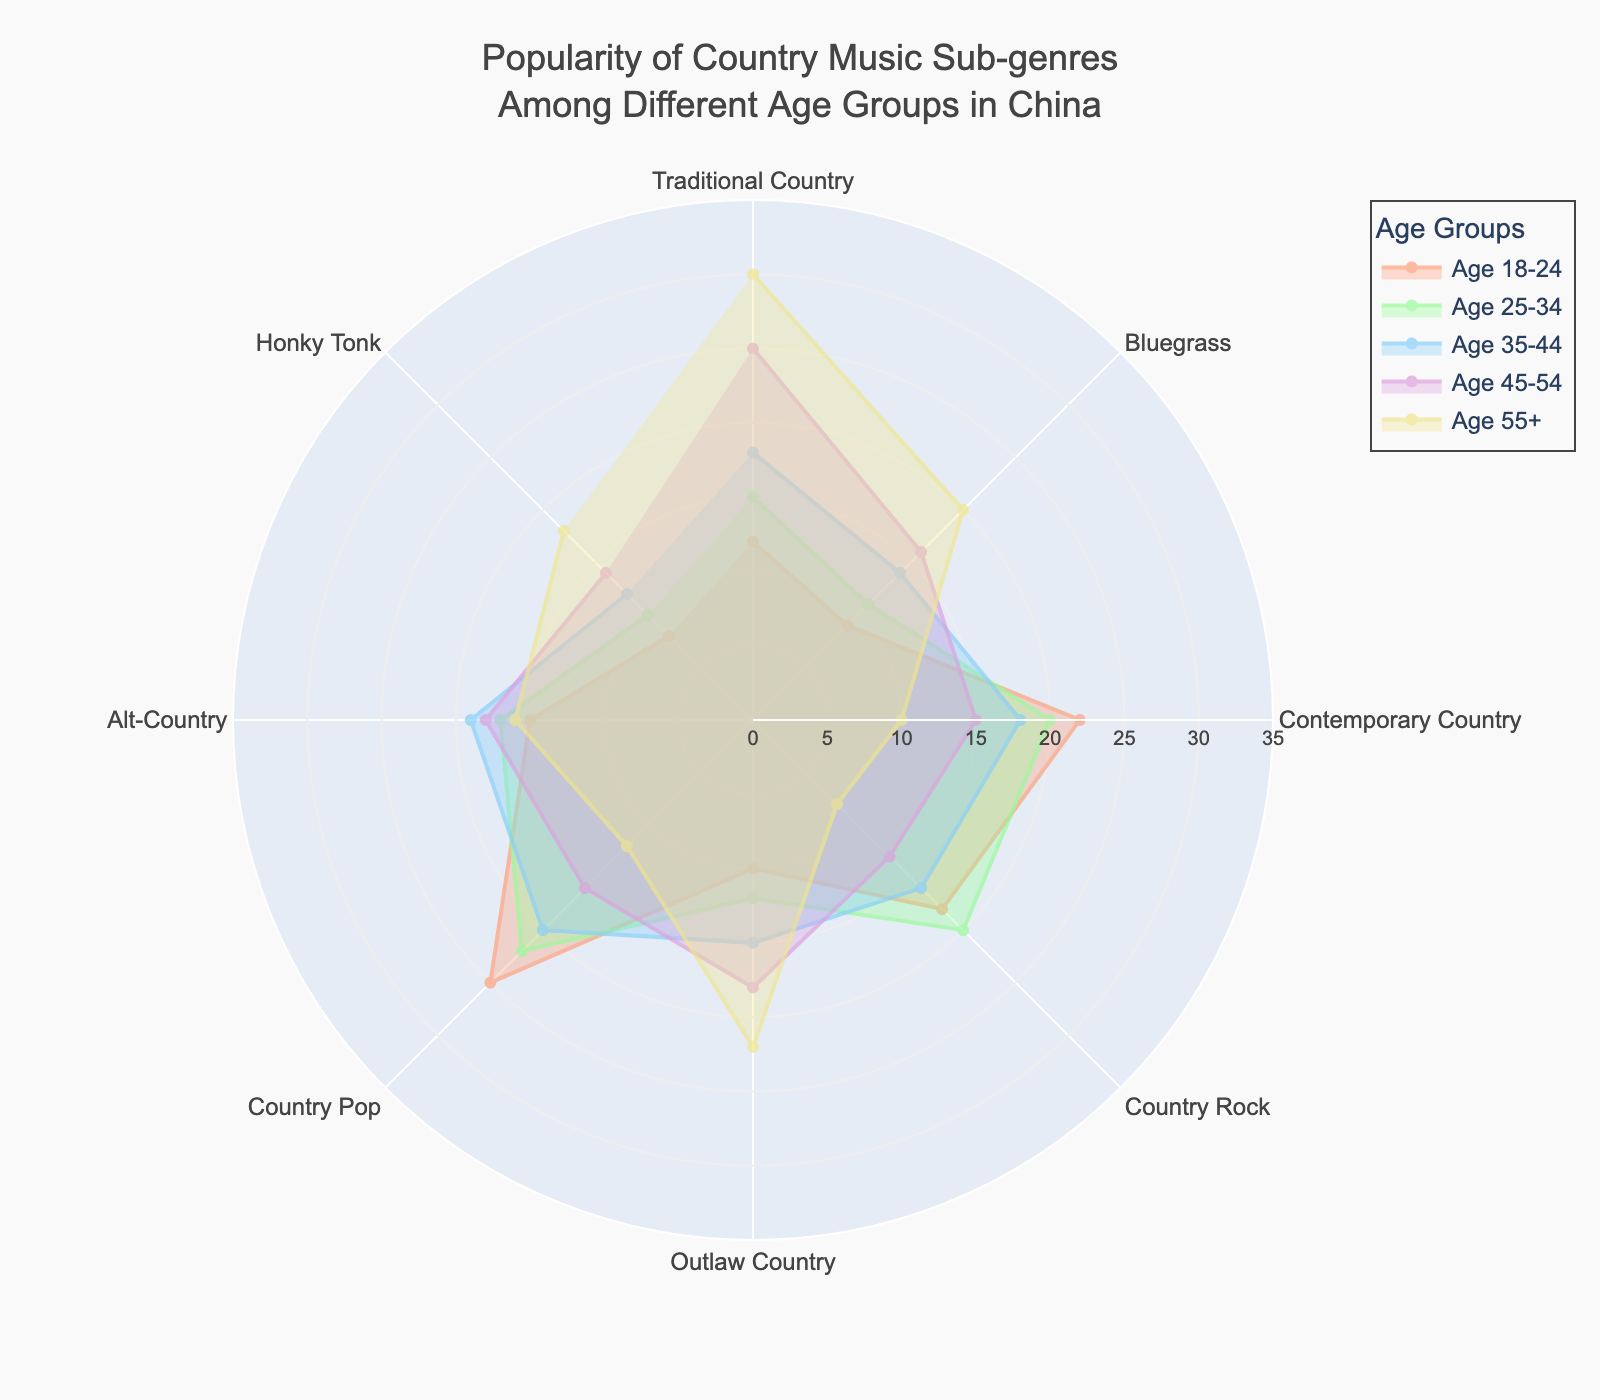What is the title of the chart? The title of the chart is clearly displayed at the top center of the radar chart.
Answer: Popularity of Country Music Sub-genres Among Different Age Groups in China How many age groups are represented in the radar chart? The legend shows the number of age groups. Each age group has a different color and label.
Answer: 5 Which sub-genre is most popular among the 18-24 age group? Check the values of each sub-genre for the 18-24 age group and identify the highest value. 'Country Pop' has the highest value of 25 among this age group.
Answer: Country Pop What is the least popular sub-genre among the 55+ age group? Look at the 55+ age group values for all sub-genres and identify the smallest number. 'Country Rock' has the smallest value, which is 8.
Answer: Country Rock Which age group shows the highest preference for Traditional Country music? Check the values for the 'Traditional Country' sub-genre across all age groups. The highest value is 30 in the 55+ age group.
Answer: 55+ What is the average popularity value of Alt-Country across all age groups? The values for 'Alt-Country' are 15, 17, 19, 18, and 16. Sum these values and divide by 5. So, (15+17+19+18+16)/5 = 17.
Answer: 17 Which sub-genre sees a consistent increase in popularity with increasing age groups? Compare the values across the age groups for each sub-genre. 'Traditional Country' shows increasing values: 12, 15, 18, 25, and 30.
Answer: Traditional Country Which two sub-genres have almost equal popularity among the 35-44 age group? Find two sub-genres with values close to each other for the '35-44' age group. 'Traditional Country' (18) and 'Contemporary Country' (18) are equal in popularity here.
Answer: Traditional Country and Contemporary Country How does the popularity of Contemporary Country change with age groups? Examine the values for 'Contemporary Country': 22, 20, 18, 15, 10. It decreases as the age increases.
Answer: It decreases For the 25-34 age group, what is the difference in popularity between Bluegrass and Honky Tonk? Subtract the value for 'Honky Tonk' (10) from the value for 'Bluegrass' (11) in the 25-34 age group. So, 11 - 10 = 1.
Answer: 1 